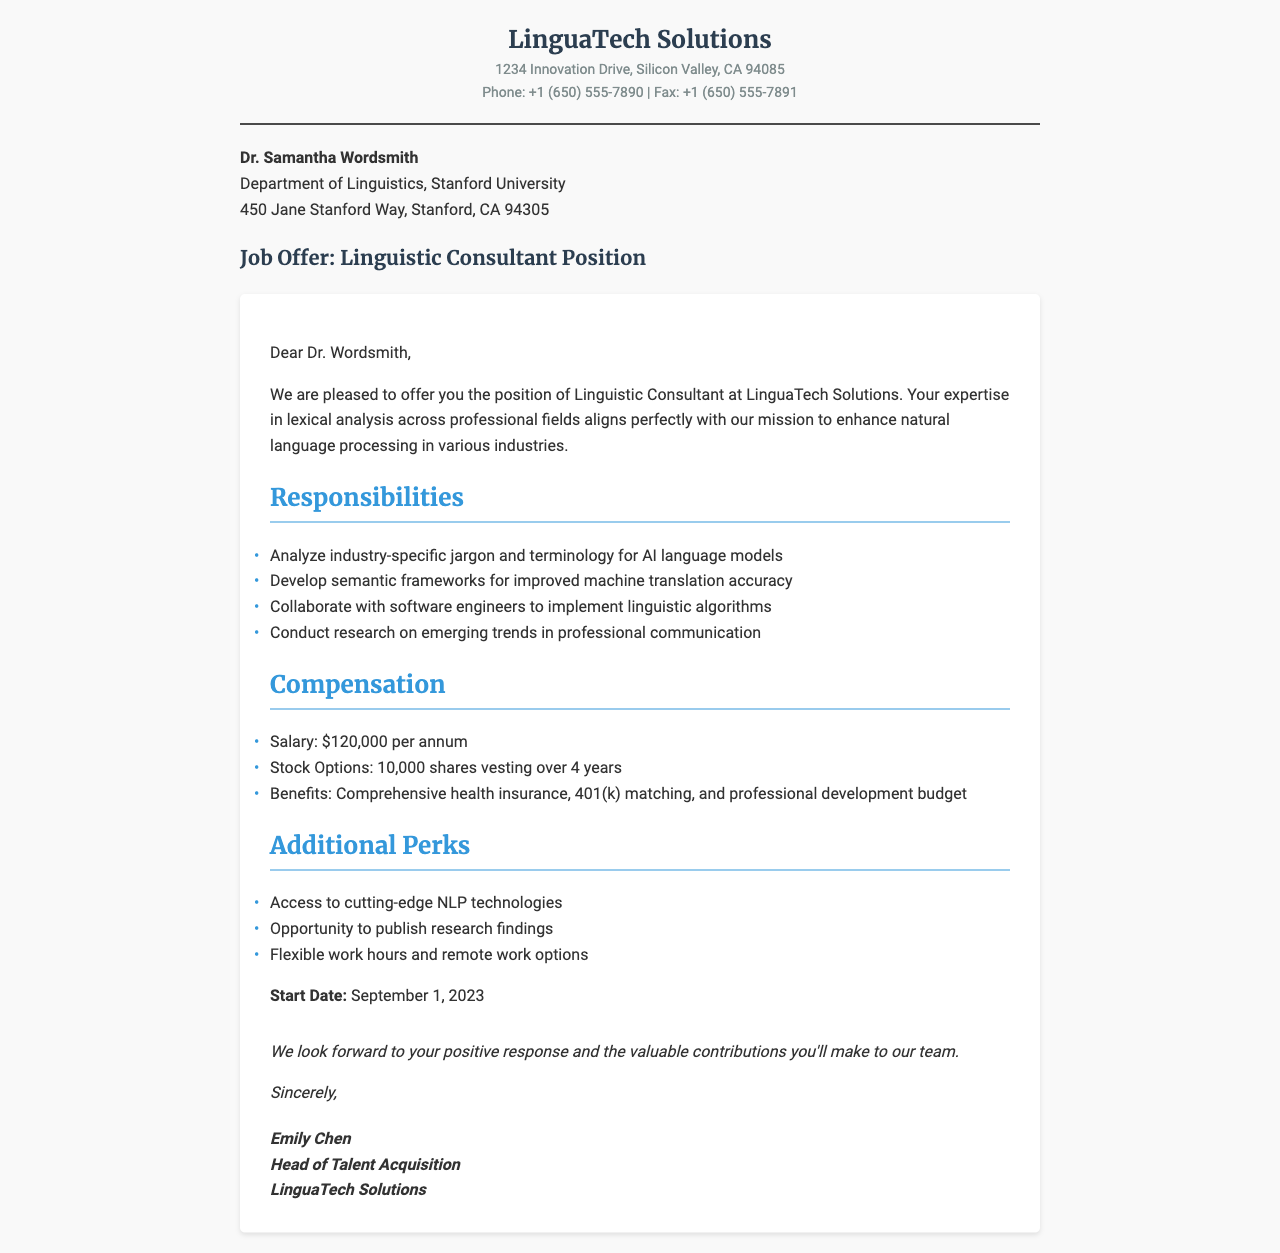What is the job title being offered? The job title mentioned in the document is "Linguistic Consultant."
Answer: Linguistic Consultant What company is making the job offer? The company making the offer is named "LinguaTech Solutions."
Answer: LinguaTech Solutions What is the starting salary for the position? The document states that the salary offered is "$120,000 per annum."
Answer: $120,000 per annum What are the stock options being provided? The stock options provided include "10,000 shares vesting over 4 years."
Answer: 10,000 shares vesting over 4 years What is one of the responsibilities of the Linguistic Consultant? The document lists several responsibilities, one being to "Analyze industry-specific jargon and terminology for AI language models."
Answer: Analyze industry-specific jargon and terminology for AI language models What is the start date for the position? The start date mentioned in the document is "September 1, 2023."
Answer: September 1, 2023 What kind of benefits are offered? The document outlines that benefits include "Comprehensive health insurance, 401(k) matching, and professional development budget."
Answer: Comprehensive health insurance, 401(k) matching, and professional development budget What type of work options are available? The document mentions "Flexible work hours and remote work options" as available work options.
Answer: Flexible work hours and remote work options Who is the sender of this job offer? The job offer is sent by "Emily Chen," who is the Head of Talent Acquisition.
Answer: Emily Chen 